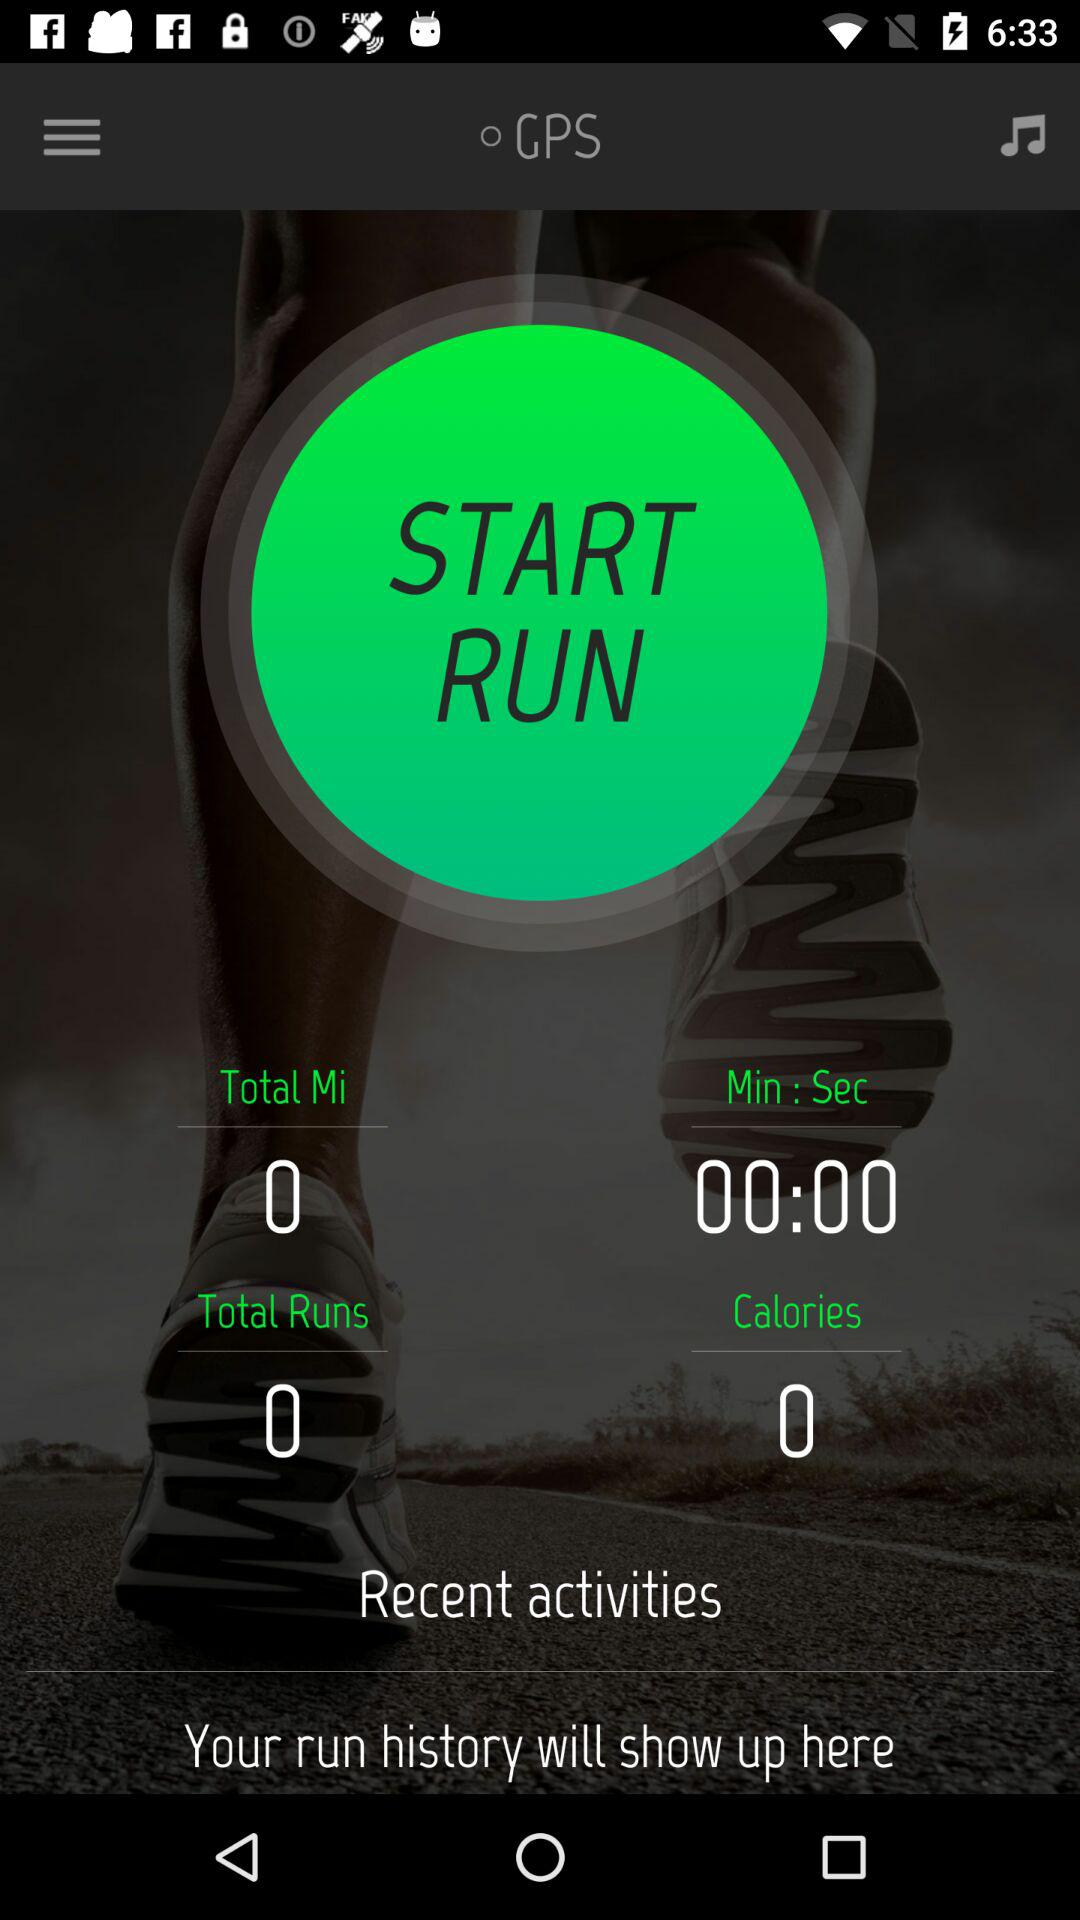What is the distance covered in total? The distance covered in total is 0 miles. 